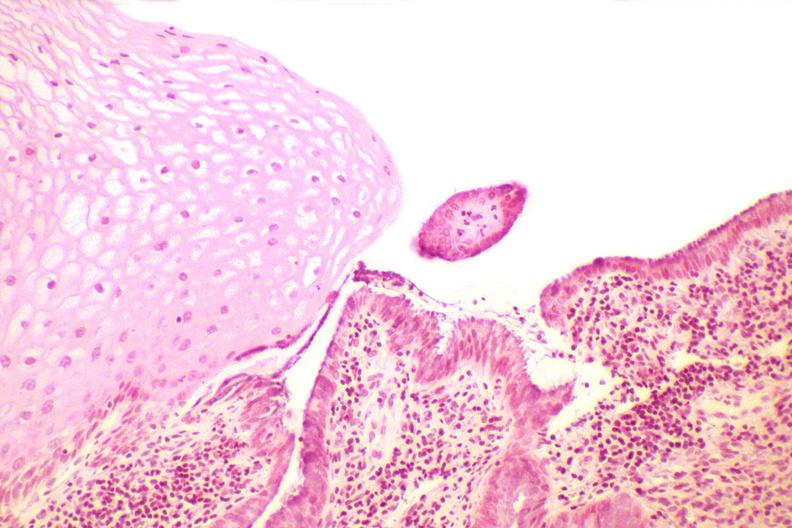s female reproductive present?
Answer the question using a single word or phrase. Yes 